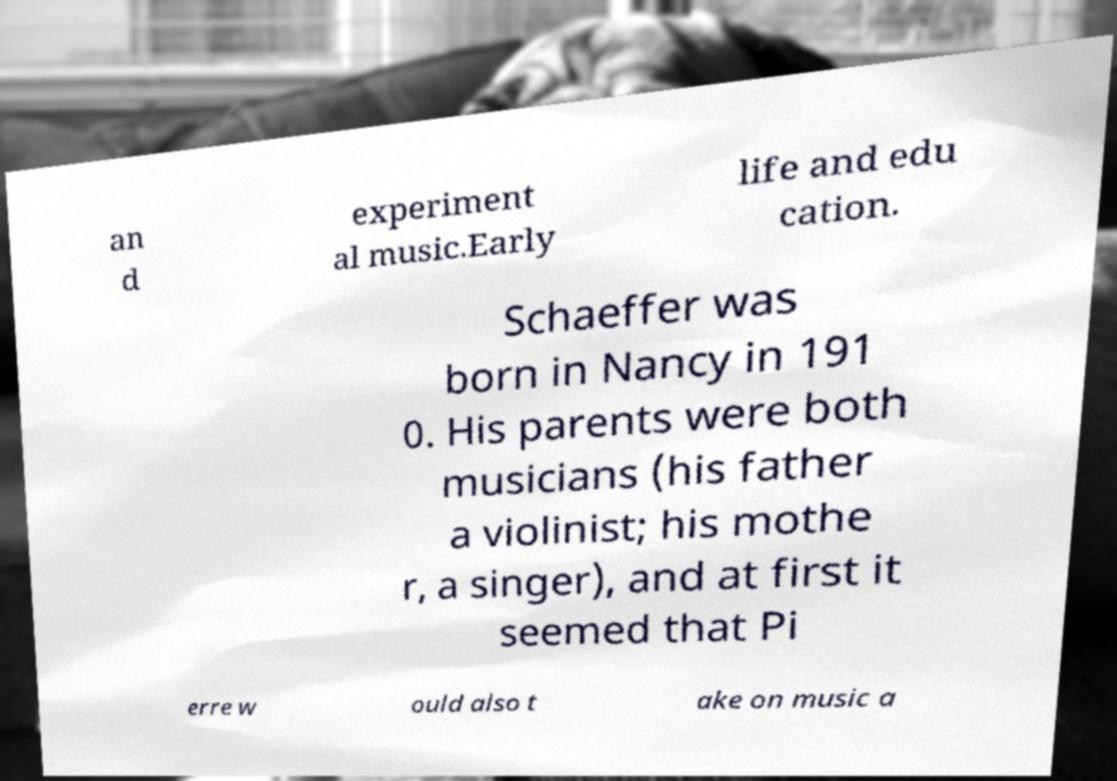For documentation purposes, I need the text within this image transcribed. Could you provide that? an d experiment al music.Early life and edu cation. Schaeffer was born in Nancy in 191 0. His parents were both musicians (his father a violinist; his mothe r, a singer), and at first it seemed that Pi erre w ould also t ake on music a 